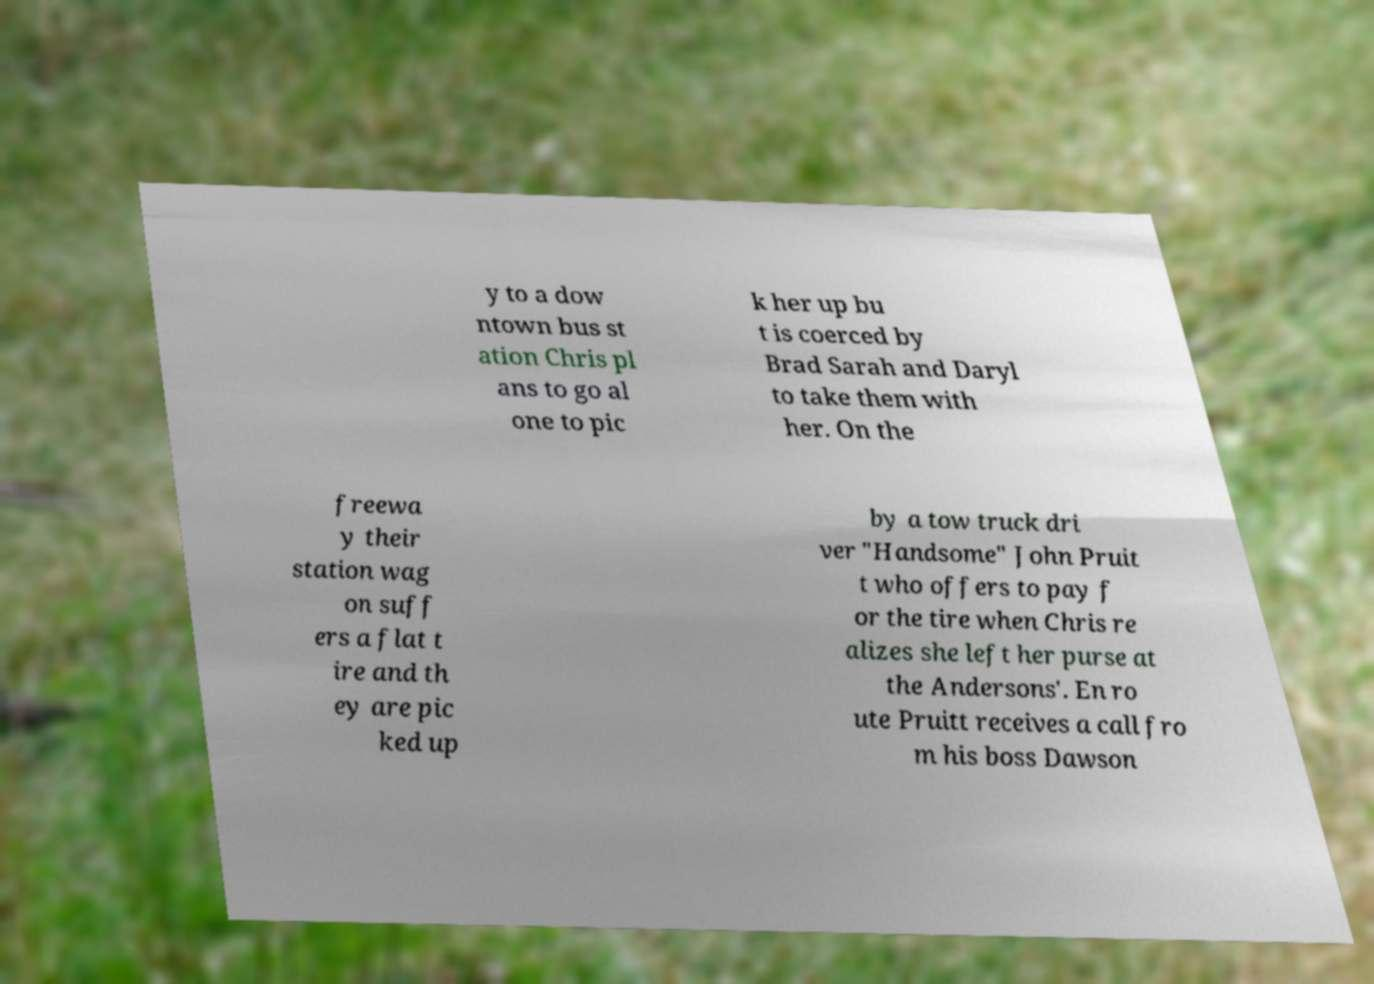Can you accurately transcribe the text from the provided image for me? y to a dow ntown bus st ation Chris pl ans to go al one to pic k her up bu t is coerced by Brad Sarah and Daryl to take them with her. On the freewa y their station wag on suff ers a flat t ire and th ey are pic ked up by a tow truck dri ver "Handsome" John Pruit t who offers to pay f or the tire when Chris re alizes she left her purse at the Andersons'. En ro ute Pruitt receives a call fro m his boss Dawson 